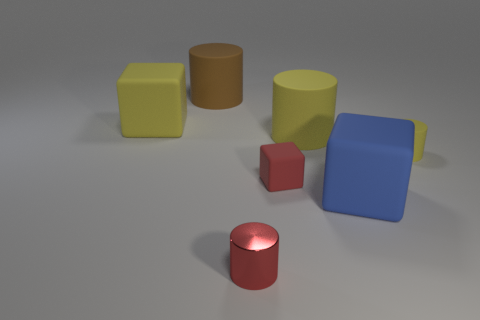There is another thing that is the same color as the metallic object; what material is it?
Your answer should be very brief. Rubber. Is the size of the blue matte block the same as the red matte cube?
Keep it short and to the point. No. Are there any big rubber objects in front of the big block that is on the left side of the large brown rubber thing?
Offer a terse response. Yes. There is a matte block that is the same color as the small metallic object; what size is it?
Offer a terse response. Small. What shape is the shiny thing left of the tiny cube?
Your response must be concise. Cylinder. What number of large matte cylinders are right of the thing behind the block behind the small matte cube?
Offer a terse response. 1. Is the size of the red cube the same as the rubber block on the left side of the tiny red cylinder?
Make the answer very short. No. There is a matte thing behind the large yellow matte object that is on the left side of the small rubber cube; how big is it?
Your response must be concise. Large. What number of large yellow cubes are made of the same material as the small block?
Your response must be concise. 1. Are any blue cubes visible?
Make the answer very short. Yes. 